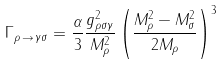<formula> <loc_0><loc_0><loc_500><loc_500>\Gamma _ { \rho \, \to \, \gamma \sigma } = \frac { \alpha } { 3 } \frac { g _ { \rho \sigma \gamma } ^ { 2 } } { M _ { \rho } ^ { 2 } } \left ( \frac { M _ { \rho } ^ { 2 } - M _ { \sigma } ^ { 2 } } { 2 M _ { \rho } } \right ) ^ { 3 }</formula> 